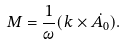<formula> <loc_0><loc_0><loc_500><loc_500>M = \frac { 1 } { \omega } ( k \times \dot { A _ { 0 } } ) .</formula> 